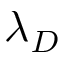<formula> <loc_0><loc_0><loc_500><loc_500>\lambda _ { D }</formula> 